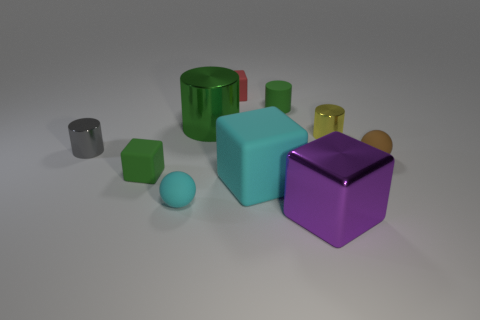What material is the other large cylinder that is the same color as the matte cylinder?
Ensure brevity in your answer.  Metal. What number of brown objects are either small matte cylinders or big metal objects?
Make the answer very short. 0. What is the block that is in front of the tiny cyan matte ball made of?
Provide a short and direct response. Metal. Is the material of the ball right of the tiny red block the same as the small green cube?
Provide a short and direct response. Yes. What is the shape of the tiny cyan thing?
Provide a succinct answer. Sphere. There is a tiny green rubber object behind the small object that is to the right of the yellow cylinder; how many small rubber spheres are to the left of it?
Offer a very short reply. 1. How many other things are the same material as the brown object?
Your answer should be very brief. 5. What is the material of the other block that is the same size as the cyan matte cube?
Your response must be concise. Metal. There is a rubber object that is to the left of the small cyan ball; is it the same color as the cylinder that is behind the green metallic object?
Offer a very short reply. Yes. Are there any small cyan matte things that have the same shape as the brown rubber thing?
Offer a very short reply. Yes. 